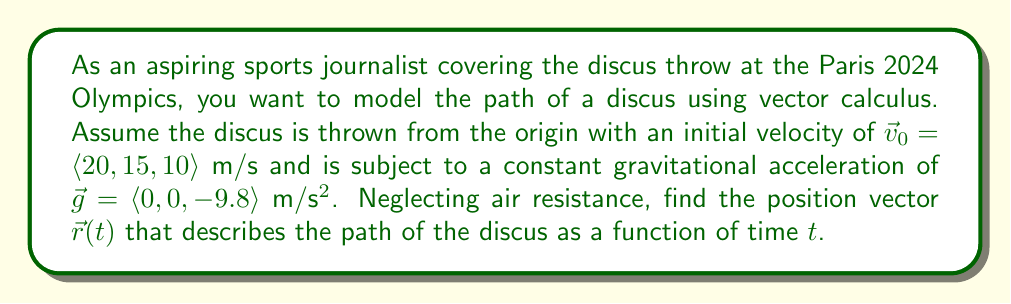Solve this math problem. To model the path of the discus throw using vector calculus, we need to consider the equations of motion for a projectile under constant acceleration. Let's approach this step-by-step:

1) The acceleration vector is constant and given by gravity:
   $\vec{a}(t) = \vec{g} = \langle 0, 0, -9.8 \rangle$ m/s²

2) To find the velocity vector $\vec{v}(t)$, we integrate the acceleration with respect to time:
   $$\vec{v}(t) = \int \vec{a}(t) dt = \vec{g}t + \vec{C}$$
   Where $\vec{C}$ is the constant of integration, which is the initial velocity $\vec{v}_0$.

3) Therefore, the velocity vector is:
   $$\vec{v}(t) = \vec{g}t + \vec{v}_0 = \langle 0, 0, -9.8 \rangle t + \langle 20, 15, 10 \rangle$$
   $$\vec{v}(t) = \langle 20, 15, 10 - 9.8t \rangle$$

4) To find the position vector $\vec{r}(t)$, we integrate the velocity vector:
   $$\vec{r}(t) = \int \vec{v}(t) dt = \int (\vec{g}t + \vec{v}_0) dt$$

5) Integrating each component:
   $$\vec{r}(t) = \frac{1}{2}\vec{g}t^2 + \vec{v}_0t + \vec{C}$$
   Where $\vec{C}$ is the initial position, which is the origin $(0,0,0)$ in this case.

6) Substituting the values:
   $$\vec{r}(t) = \frac{1}{2}\langle 0, 0, -9.8 \rangle t^2 + \langle 20, 15, 10 \rangle t + \langle 0, 0, 0 \rangle$$

7) Simplifying:
   $$\vec{r}(t) = \langle 20t, 15t, 10t - 4.9t^2 \rangle$$

This vector-valued function describes the position of the discus at any time $t$.
Answer: $\vec{r}(t) = \langle 20t, 15t, 10t - 4.9t^2 \rangle$ meters 